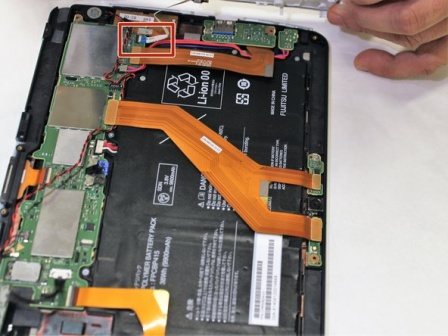What's happening in the scene? The image captures a moment of intricate technology exploration. A hand, poised with a white stylus, hovers over the exposed innards of a tablet device. The device, lying open on a white surface, reveals a complex network of components connected by a web of orange and red cables. The black battery, a dominant feature, occupies a substantial portion of the device's interior. Each component, meticulously placed, contributes to the overall functionality of the tablet. The image is a testament to the intricate design and assembly of modern technology. 